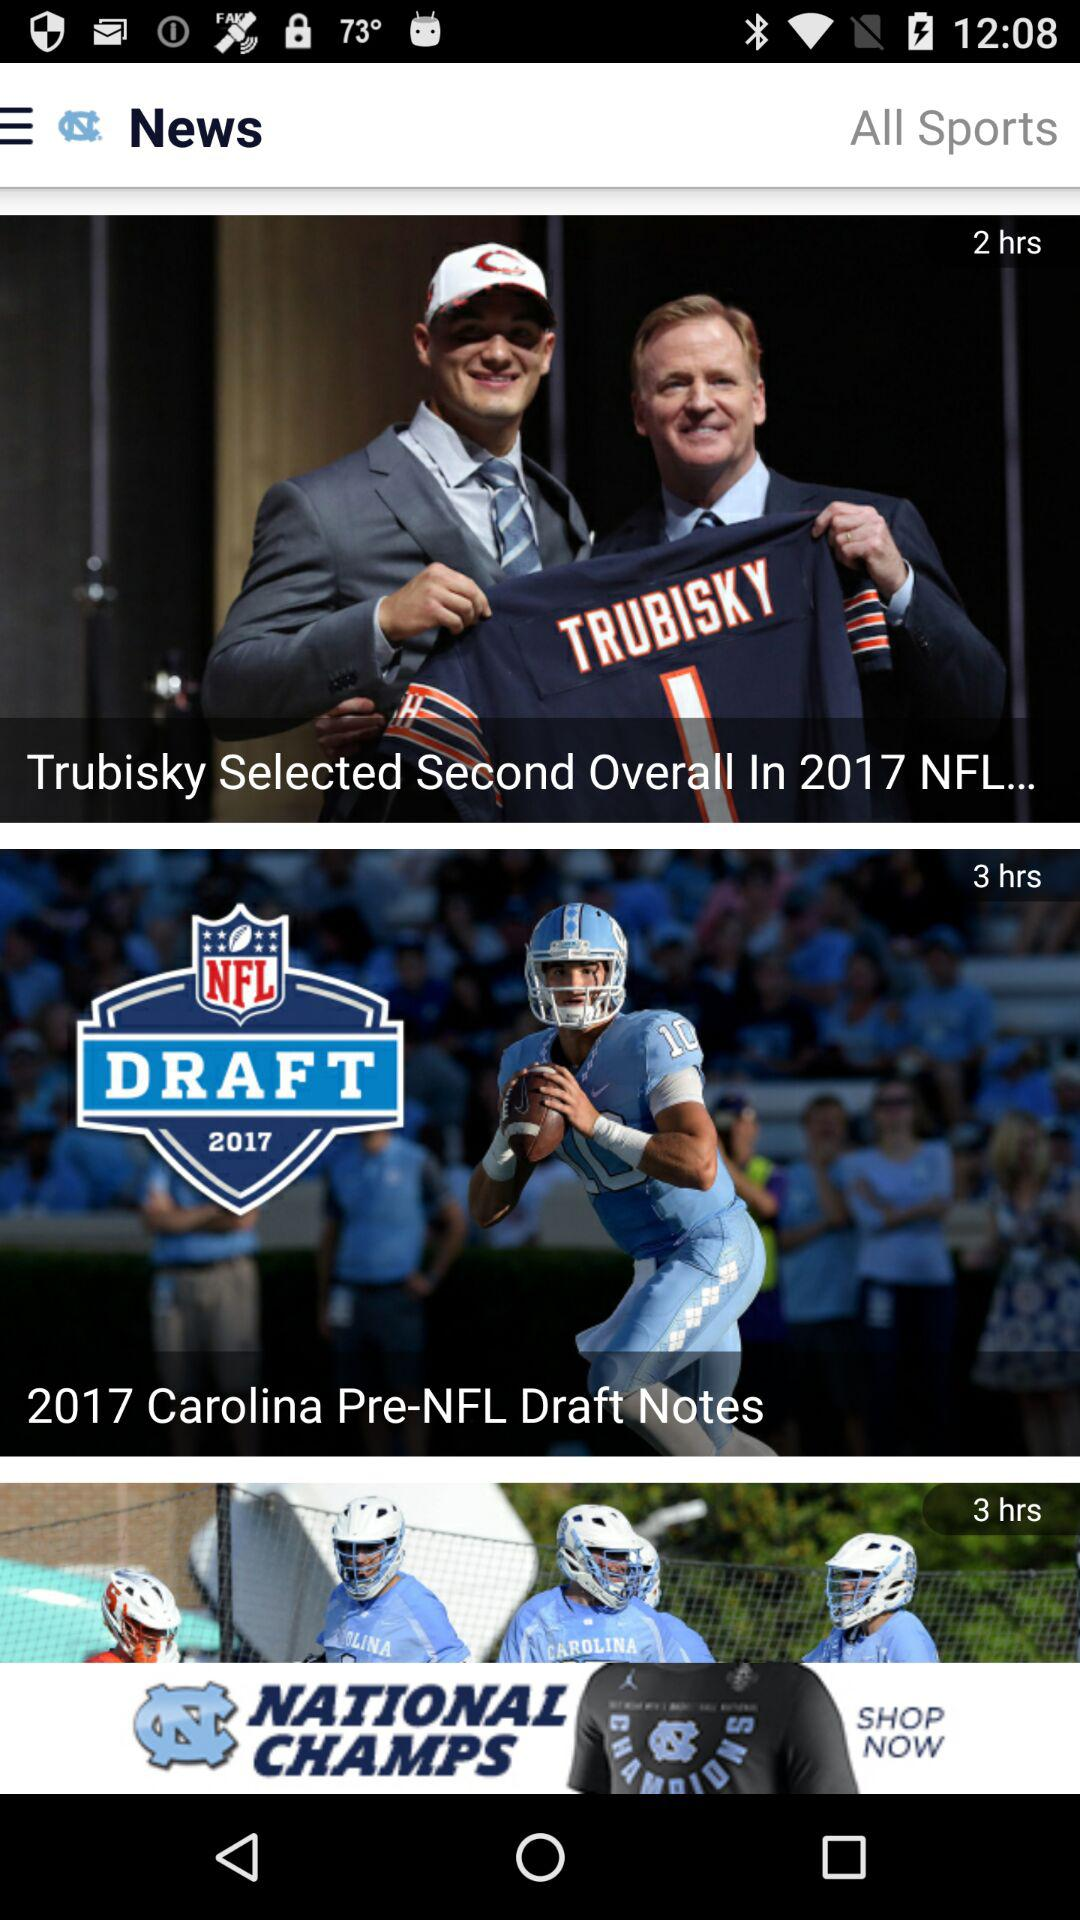What is the last post uploaded?
When the provided information is insufficient, respond with <no answer>. <no answer> 